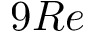Convert formula to latex. <formula><loc_0><loc_0><loc_500><loc_500>9 R e</formula> 